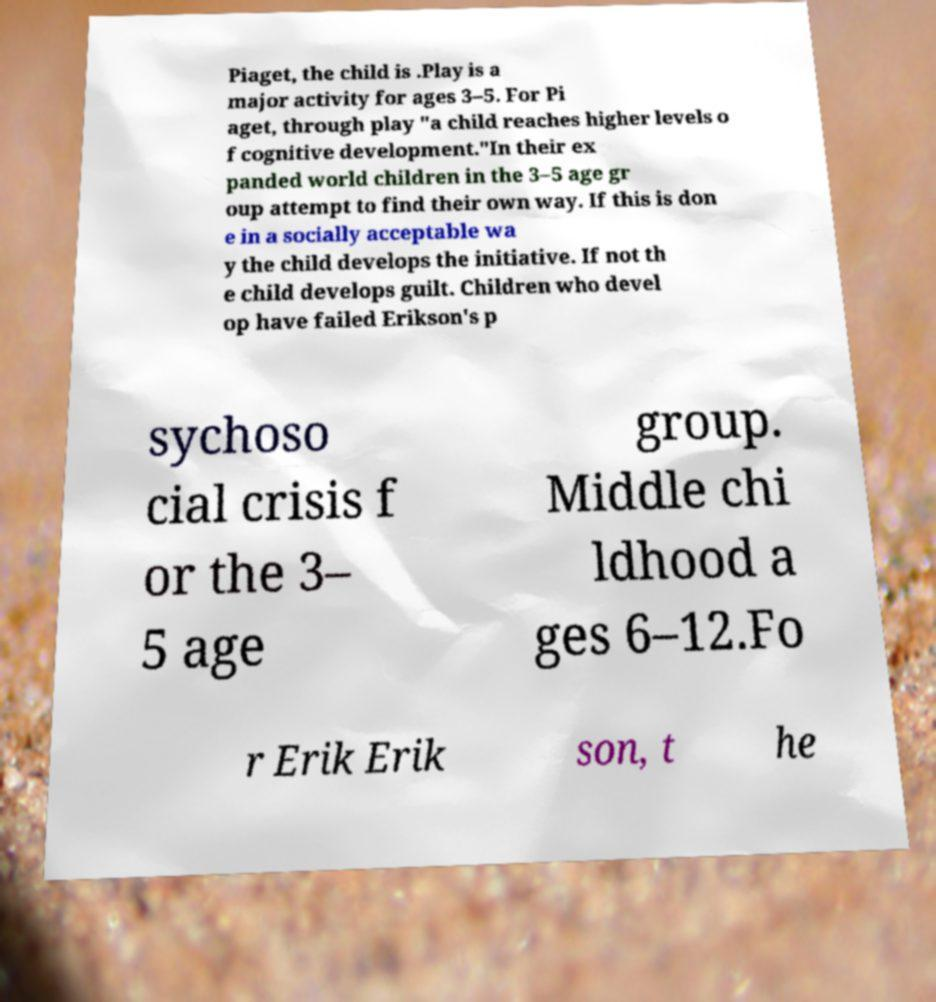What messages or text are displayed in this image? I need them in a readable, typed format. Piaget, the child is .Play is a major activity for ages 3–5. For Pi aget, through play "a child reaches higher levels o f cognitive development."In their ex panded world children in the 3–5 age gr oup attempt to find their own way. If this is don e in a socially acceptable wa y the child develops the initiative. If not th e child develops guilt. Children who devel op have failed Erikson's p sychoso cial crisis f or the 3– 5 age group. Middle chi ldhood a ges 6–12.Fo r Erik Erik son, t he 